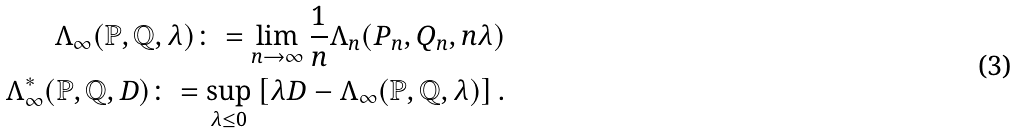Convert formula to latex. <formula><loc_0><loc_0><loc_500><loc_500>\Lambda _ { \infty } ( \mathbb { P } , \mathbb { Q } , \lambda ) \colon = \lim _ { n \to \infty } \frac { 1 } { n } \Lambda _ { n } ( P _ { n } , Q _ { n } , n \lambda ) \\ \Lambda _ { \infty } ^ { * } ( \mathbb { P } , \mathbb { Q } , D ) \colon = \sup _ { \lambda \leq 0 } \left [ \lambda D - \Lambda _ { \infty } ( \mathbb { P } , \mathbb { Q } , \lambda ) \right ] .</formula> 